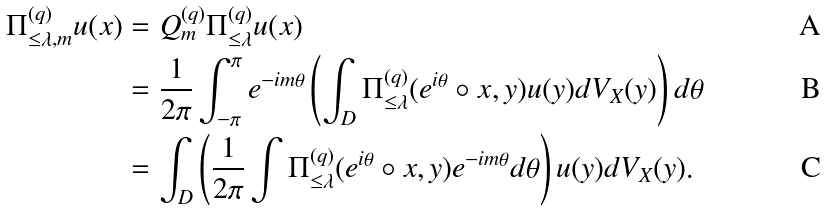Convert formula to latex. <formula><loc_0><loc_0><loc_500><loc_500>\Pi ^ { ( q ) } _ { \leq \lambda , m } u ( x ) & = Q _ { m } ^ { ( q ) } \Pi ^ { ( q ) } _ { \leq \lambda } u ( x ) \\ & = \frac { 1 } { 2 \pi } \int _ { - \pi } ^ { \pi } e ^ { - i m \theta } \left ( \int _ { D } \Pi ^ { ( q ) } _ { \leq \lambda } ( e ^ { i \theta } \circ x , y ) u ( y ) d V _ { X } ( y ) \right ) d \theta \\ & = \int _ { D } \left ( \frac { 1 } { 2 \pi } \int \Pi ^ { ( q ) } _ { \leq \lambda } ( e ^ { i \theta } \circ x , y ) e ^ { - i m \theta } d \theta \right ) u ( y ) d V _ { X } ( y ) .</formula> 